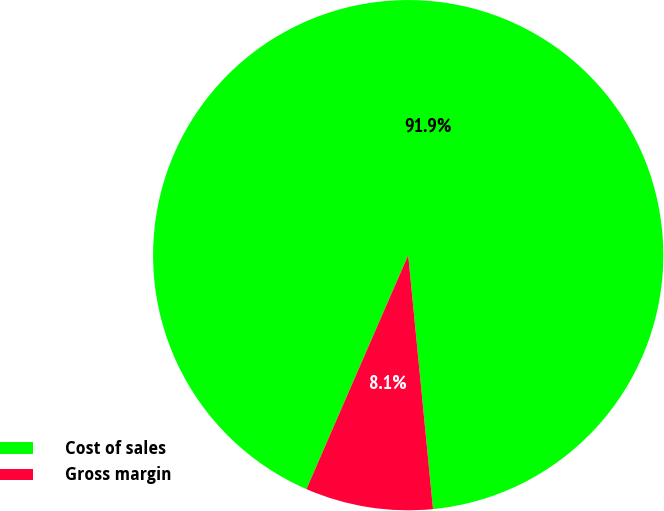<chart> <loc_0><loc_0><loc_500><loc_500><pie_chart><fcel>Cost of sales<fcel>Gross margin<nl><fcel>91.92%<fcel>8.08%<nl></chart> 